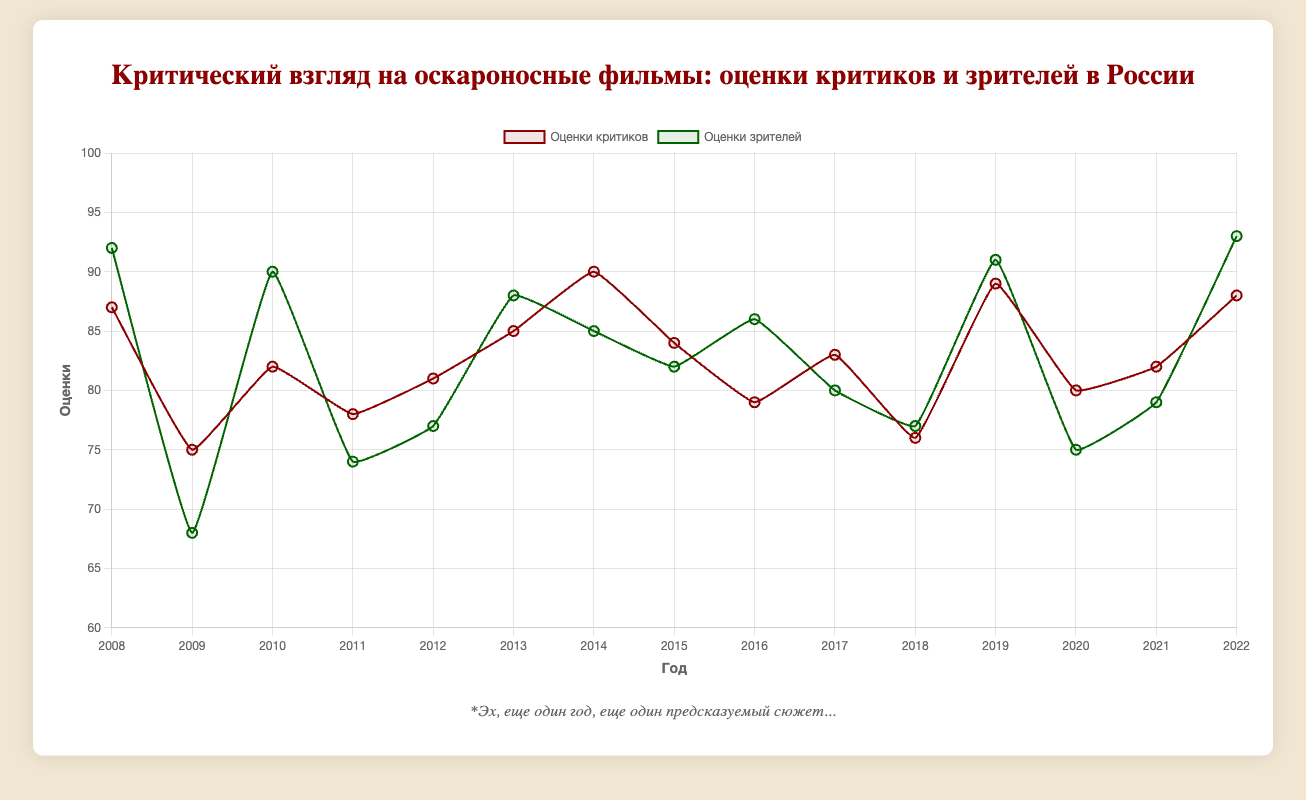In which year was the difference between critics' and audience scores the largest? To find this, calculate the absolute difference for each year and identify the largest. The differences for each year are: 5, 7, 8, 4, 4, 3, 5, 2, 7, 3, 1, 2, 5, 3, 5. The largest difference is 8, and it occurs in 2010.
Answer: 2010 Which film received the highest audience score? Look at the audience scores and identify the highest value. The highest score is 93, which corresponds to the film "Everything Everywhere All at Once" in 2022.
Answer: Everything Everywhere All at Once By how many points was "The Hurt Locker" rated higher by critics than by the audience? Find "The Hurt Locker" in the list, which is in 2009. The critics' score is 75, and the audience score is 68. The difference is 75 - 68.
Answer: 7 points What is the average critics' score for the Oscar-winning films shown? Sum the critics' scores and divide by the number of films: (87+75+82+78+81+85+90+84+79+83+76+89+80+82+88) / 15 = 81.33
Answer: 81.33 Comparing 2017 and 2021, which year had higher audience scores for the Oscar-winning films? The audience score in 2017 is 80, and in 2021 it is 79.
Answer: 2017 Which year(s) had the lowest audience score? Identify the minimum audience score, which is 68, and locate the corresponding year. The lowest audience score is in 2009.
Answer: 2009 What was the trend in critics' scores from 2018 to 2020? Examine the values for critics' scores from 2018 to 2020: 76 (2018) to 89 (2019) to 80 (2020). The scores initially increased and then decreased.
Answer: Increased then decreased In how many years was the audience score higher than the critics' score? Compare each year's critics' and audience scores. The audience scores are higher in 2008, 2010, 2013, 2016, 2019, and 2022. There are 6 such years.
Answer: 6 years Which year had the smallest difference between critics' and audience scores? Calculate the absolute differences for each year and find the smallest. The smallest difference is 1 point in 2018.
Answer: 2018 